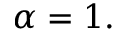<formula> <loc_0><loc_0><loc_500><loc_500>\alpha = 1 .</formula> 